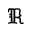Convert formula to latex. <formula><loc_0><loc_0><loc_500><loc_500>\mathfrak { R }</formula> 